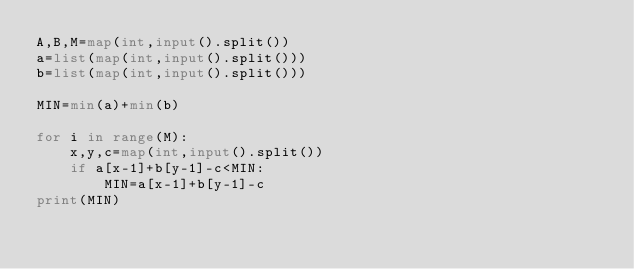Convert code to text. <code><loc_0><loc_0><loc_500><loc_500><_Python_>A,B,M=map(int,input().split())
a=list(map(int,input().split()))
b=list(map(int,input().split()))

MIN=min(a)+min(b)

for i in range(M):
    x,y,c=map(int,input().split())
    if a[x-1]+b[y-1]-c<MIN:
        MIN=a[x-1]+b[y-1]-c
print(MIN)</code> 